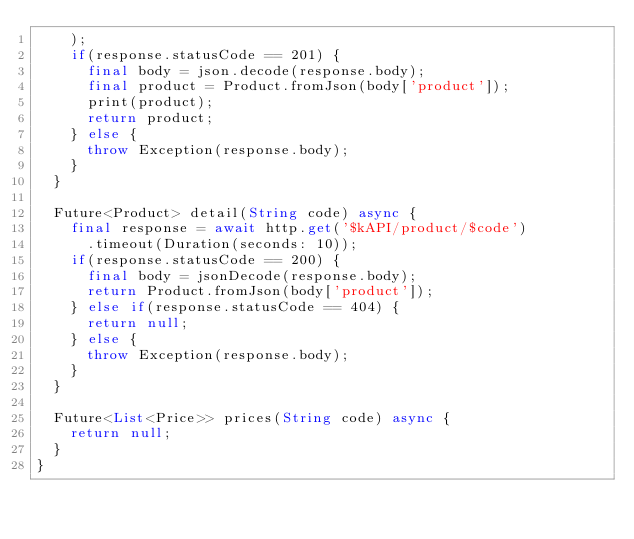Convert code to text. <code><loc_0><loc_0><loc_500><loc_500><_Dart_>    );
    if(response.statusCode == 201) {
      final body = json.decode(response.body);
      final product = Product.fromJson(body['product']);
      print(product);
      return product;
    } else {
      throw Exception(response.body);
    }
  }

  Future<Product> detail(String code) async {
    final response = await http.get('$kAPI/product/$code')
      .timeout(Duration(seconds: 10));
    if(response.statusCode == 200) {
      final body = jsonDecode(response.body);
      return Product.fromJson(body['product']);
    } else if(response.statusCode == 404) {
      return null;
    } else {
      throw Exception(response.body);
    }
  }

  Future<List<Price>> prices(String code) async {
    return null;
  }
}</code> 